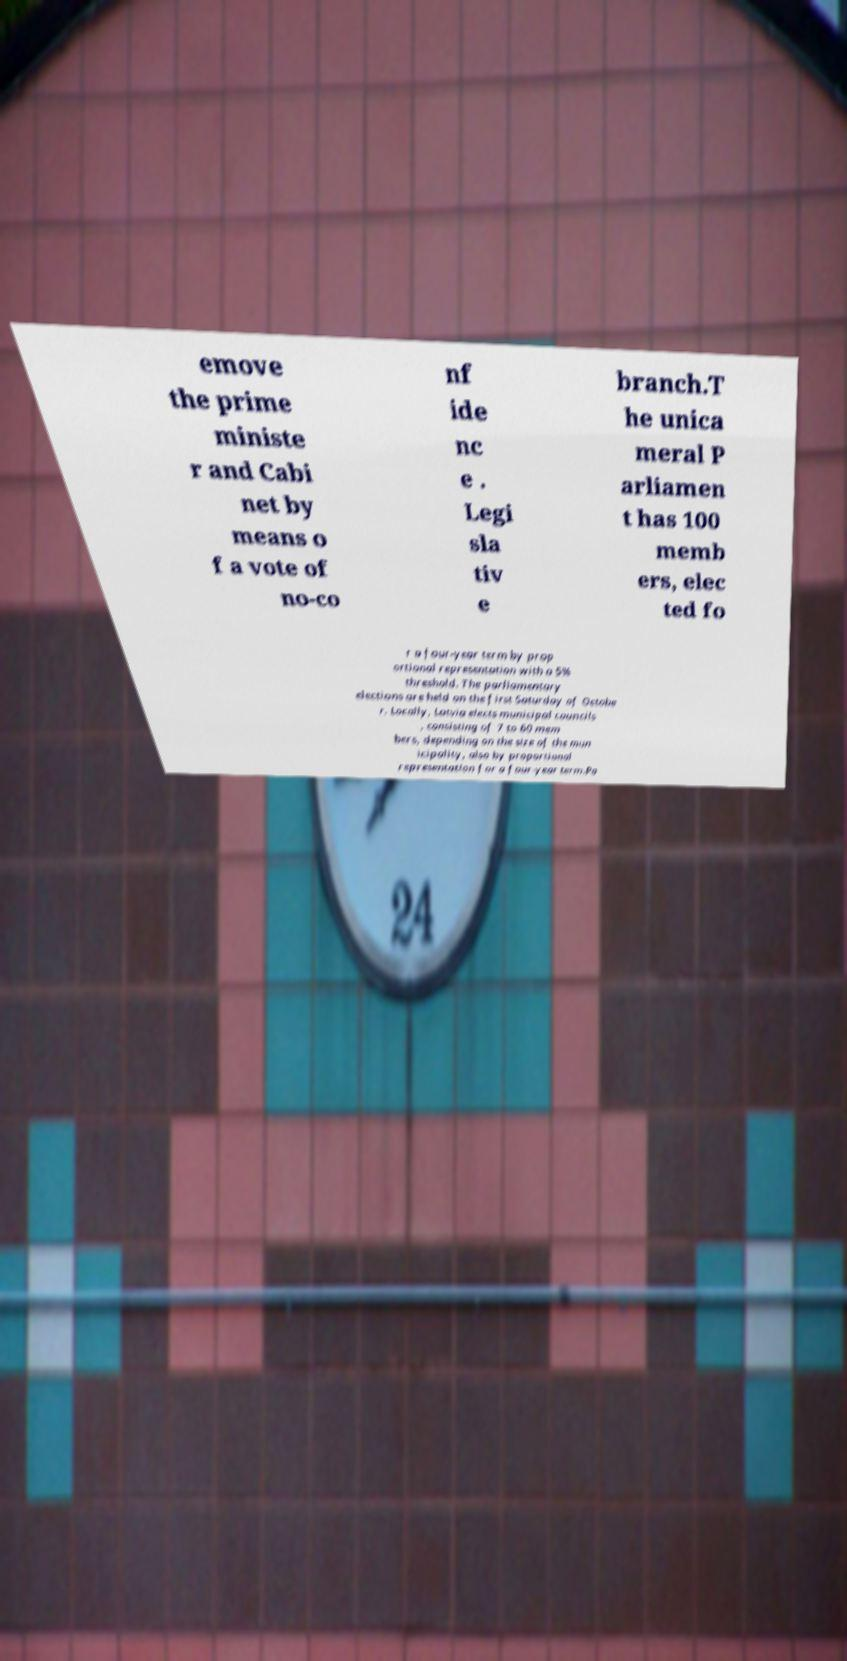Can you accurately transcribe the text from the provided image for me? emove the prime ministe r and Cabi net by means o f a vote of no-co nf ide nc e . Legi sla tiv e branch.T he unica meral P arliamen t has 100 memb ers, elec ted fo r a four-year term by prop ortional representation with a 5% threshold. The parliamentary elections are held on the first Saturday of Octobe r. Locally, Latvia elects municipal councils , consisting of 7 to 60 mem bers, depending on the size of the mun icipality, also by proportional representation for a four-year term.Po 